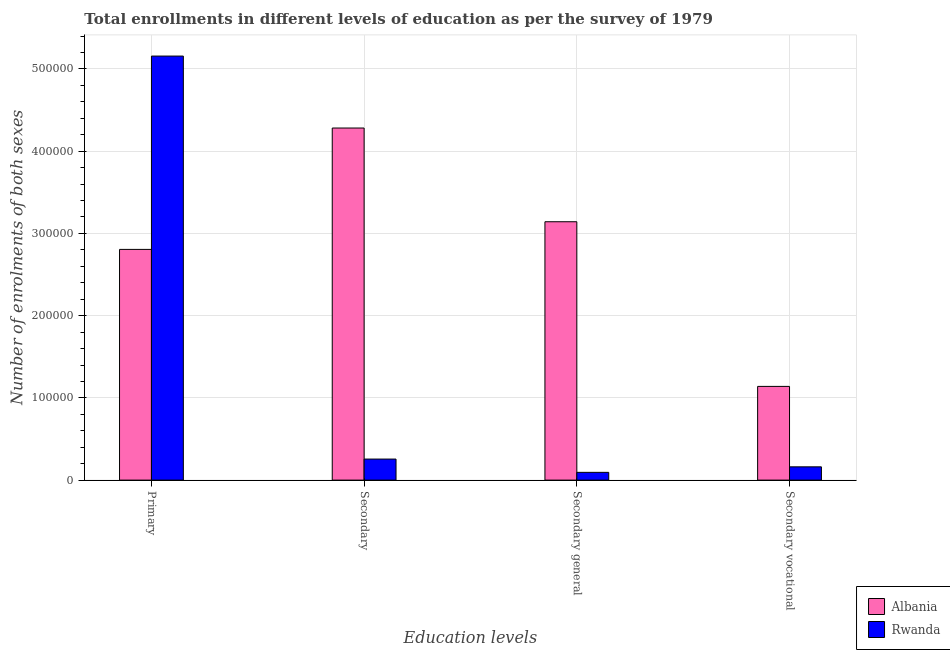How many different coloured bars are there?
Keep it short and to the point. 2. How many groups of bars are there?
Give a very brief answer. 4. What is the label of the 3rd group of bars from the left?
Your answer should be very brief. Secondary general. What is the number of enrolments in secondary general education in Albania?
Ensure brevity in your answer.  3.14e+05. Across all countries, what is the maximum number of enrolments in primary education?
Provide a short and direct response. 5.16e+05. Across all countries, what is the minimum number of enrolments in secondary vocational education?
Make the answer very short. 1.62e+04. In which country was the number of enrolments in secondary education maximum?
Your response must be concise. Albania. In which country was the number of enrolments in primary education minimum?
Make the answer very short. Albania. What is the total number of enrolments in secondary education in the graph?
Your answer should be very brief. 4.54e+05. What is the difference between the number of enrolments in secondary education in Albania and that in Rwanda?
Keep it short and to the point. 4.03e+05. What is the difference between the number of enrolments in primary education in Albania and the number of enrolments in secondary vocational education in Rwanda?
Ensure brevity in your answer.  2.64e+05. What is the average number of enrolments in secondary general education per country?
Make the answer very short. 1.62e+05. What is the difference between the number of enrolments in secondary vocational education and number of enrolments in secondary general education in Albania?
Provide a succinct answer. -2.00e+05. What is the ratio of the number of enrolments in primary education in Rwanda to that in Albania?
Ensure brevity in your answer.  1.84. Is the number of enrolments in secondary education in Albania less than that in Rwanda?
Ensure brevity in your answer.  No. What is the difference between the highest and the second highest number of enrolments in secondary general education?
Offer a very short reply. 3.05e+05. What is the difference between the highest and the lowest number of enrolments in secondary education?
Keep it short and to the point. 4.03e+05. In how many countries, is the number of enrolments in secondary general education greater than the average number of enrolments in secondary general education taken over all countries?
Give a very brief answer. 1. Is the sum of the number of enrolments in secondary general education in Rwanda and Albania greater than the maximum number of enrolments in secondary education across all countries?
Offer a terse response. No. What does the 1st bar from the left in Secondary general represents?
Your answer should be compact. Albania. What does the 2nd bar from the right in Secondary represents?
Make the answer very short. Albania. How many bars are there?
Make the answer very short. 8. How many countries are there in the graph?
Ensure brevity in your answer.  2. What is the difference between two consecutive major ticks on the Y-axis?
Provide a succinct answer. 1.00e+05. Are the values on the major ticks of Y-axis written in scientific E-notation?
Give a very brief answer. No. Does the graph contain grids?
Offer a very short reply. Yes. Where does the legend appear in the graph?
Your answer should be very brief. Bottom right. How are the legend labels stacked?
Offer a very short reply. Vertical. What is the title of the graph?
Provide a succinct answer. Total enrollments in different levels of education as per the survey of 1979. What is the label or title of the X-axis?
Offer a terse response. Education levels. What is the label or title of the Y-axis?
Your answer should be compact. Number of enrolments of both sexes. What is the Number of enrolments of both sexes in Albania in Primary?
Make the answer very short. 2.81e+05. What is the Number of enrolments of both sexes in Rwanda in Primary?
Offer a very short reply. 5.16e+05. What is the Number of enrolments of both sexes of Albania in Secondary?
Provide a succinct answer. 4.28e+05. What is the Number of enrolments of both sexes of Rwanda in Secondary?
Make the answer very short. 2.56e+04. What is the Number of enrolments of both sexes in Albania in Secondary general?
Your response must be concise. 3.14e+05. What is the Number of enrolments of both sexes of Rwanda in Secondary general?
Ensure brevity in your answer.  9451. What is the Number of enrolments of both sexes in Albania in Secondary vocational?
Provide a short and direct response. 1.14e+05. What is the Number of enrolments of both sexes in Rwanda in Secondary vocational?
Ensure brevity in your answer.  1.62e+04. Across all Education levels, what is the maximum Number of enrolments of both sexes of Albania?
Keep it short and to the point. 4.28e+05. Across all Education levels, what is the maximum Number of enrolments of both sexes of Rwanda?
Provide a succinct answer. 5.16e+05. Across all Education levels, what is the minimum Number of enrolments of both sexes in Albania?
Ensure brevity in your answer.  1.14e+05. Across all Education levels, what is the minimum Number of enrolments of both sexes in Rwanda?
Offer a terse response. 9451. What is the total Number of enrolments of both sexes in Albania in the graph?
Offer a terse response. 1.14e+06. What is the total Number of enrolments of both sexes of Rwanda in the graph?
Provide a succinct answer. 5.67e+05. What is the difference between the Number of enrolments of both sexes of Albania in Primary and that in Secondary?
Keep it short and to the point. -1.48e+05. What is the difference between the Number of enrolments of both sexes in Rwanda in Primary and that in Secondary?
Your response must be concise. 4.90e+05. What is the difference between the Number of enrolments of both sexes in Albania in Primary and that in Secondary general?
Your answer should be very brief. -3.36e+04. What is the difference between the Number of enrolments of both sexes in Rwanda in Primary and that in Secondary general?
Offer a very short reply. 5.06e+05. What is the difference between the Number of enrolments of both sexes of Albania in Primary and that in Secondary vocational?
Provide a succinct answer. 1.67e+05. What is the difference between the Number of enrolments of both sexes in Rwanda in Primary and that in Secondary vocational?
Make the answer very short. 5.00e+05. What is the difference between the Number of enrolments of both sexes of Albania in Secondary and that in Secondary general?
Your answer should be very brief. 1.14e+05. What is the difference between the Number of enrolments of both sexes in Rwanda in Secondary and that in Secondary general?
Give a very brief answer. 1.62e+04. What is the difference between the Number of enrolments of both sexes in Albania in Secondary and that in Secondary vocational?
Offer a terse response. 3.14e+05. What is the difference between the Number of enrolments of both sexes of Rwanda in Secondary and that in Secondary vocational?
Provide a succinct answer. 9451. What is the difference between the Number of enrolments of both sexes of Albania in Secondary general and that in Secondary vocational?
Offer a terse response. 2.00e+05. What is the difference between the Number of enrolments of both sexes of Rwanda in Secondary general and that in Secondary vocational?
Ensure brevity in your answer.  -6699. What is the difference between the Number of enrolments of both sexes in Albania in Primary and the Number of enrolments of both sexes in Rwanda in Secondary?
Ensure brevity in your answer.  2.55e+05. What is the difference between the Number of enrolments of both sexes in Albania in Primary and the Number of enrolments of both sexes in Rwanda in Secondary general?
Keep it short and to the point. 2.71e+05. What is the difference between the Number of enrolments of both sexes of Albania in Primary and the Number of enrolments of both sexes of Rwanda in Secondary vocational?
Ensure brevity in your answer.  2.64e+05. What is the difference between the Number of enrolments of both sexes of Albania in Secondary and the Number of enrolments of both sexes of Rwanda in Secondary general?
Ensure brevity in your answer.  4.19e+05. What is the difference between the Number of enrolments of both sexes in Albania in Secondary and the Number of enrolments of both sexes in Rwanda in Secondary vocational?
Offer a terse response. 4.12e+05. What is the difference between the Number of enrolments of both sexes in Albania in Secondary general and the Number of enrolments of both sexes in Rwanda in Secondary vocational?
Give a very brief answer. 2.98e+05. What is the average Number of enrolments of both sexes in Albania per Education levels?
Offer a very short reply. 2.84e+05. What is the average Number of enrolments of both sexes in Rwanda per Education levels?
Provide a succinct answer. 1.42e+05. What is the difference between the Number of enrolments of both sexes of Albania and Number of enrolments of both sexes of Rwanda in Primary?
Your response must be concise. -2.35e+05. What is the difference between the Number of enrolments of both sexes in Albania and Number of enrolments of both sexes in Rwanda in Secondary?
Your answer should be compact. 4.03e+05. What is the difference between the Number of enrolments of both sexes in Albania and Number of enrolments of both sexes in Rwanda in Secondary general?
Offer a very short reply. 3.05e+05. What is the difference between the Number of enrolments of both sexes of Albania and Number of enrolments of both sexes of Rwanda in Secondary vocational?
Provide a short and direct response. 9.78e+04. What is the ratio of the Number of enrolments of both sexes of Albania in Primary to that in Secondary?
Keep it short and to the point. 0.66. What is the ratio of the Number of enrolments of both sexes of Rwanda in Primary to that in Secondary?
Your answer should be very brief. 20.14. What is the ratio of the Number of enrolments of both sexes of Albania in Primary to that in Secondary general?
Your response must be concise. 0.89. What is the ratio of the Number of enrolments of both sexes in Rwanda in Primary to that in Secondary general?
Your answer should be compact. 54.57. What is the ratio of the Number of enrolments of both sexes of Albania in Primary to that in Secondary vocational?
Ensure brevity in your answer.  2.46. What is the ratio of the Number of enrolments of both sexes in Rwanda in Primary to that in Secondary vocational?
Ensure brevity in your answer.  31.93. What is the ratio of the Number of enrolments of both sexes in Albania in Secondary to that in Secondary general?
Your answer should be very brief. 1.36. What is the ratio of the Number of enrolments of both sexes of Rwanda in Secondary to that in Secondary general?
Keep it short and to the point. 2.71. What is the ratio of the Number of enrolments of both sexes of Albania in Secondary to that in Secondary vocational?
Provide a short and direct response. 3.76. What is the ratio of the Number of enrolments of both sexes in Rwanda in Secondary to that in Secondary vocational?
Your answer should be very brief. 1.59. What is the ratio of the Number of enrolments of both sexes in Albania in Secondary general to that in Secondary vocational?
Keep it short and to the point. 2.76. What is the ratio of the Number of enrolments of both sexes in Rwanda in Secondary general to that in Secondary vocational?
Offer a very short reply. 0.59. What is the difference between the highest and the second highest Number of enrolments of both sexes of Albania?
Your answer should be compact. 1.14e+05. What is the difference between the highest and the second highest Number of enrolments of both sexes of Rwanda?
Your answer should be very brief. 4.90e+05. What is the difference between the highest and the lowest Number of enrolments of both sexes in Albania?
Offer a terse response. 3.14e+05. What is the difference between the highest and the lowest Number of enrolments of both sexes of Rwanda?
Your response must be concise. 5.06e+05. 